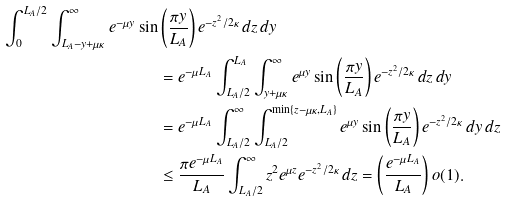Convert formula to latex. <formula><loc_0><loc_0><loc_500><loc_500>\int _ { 0 } ^ { L _ { A } / 2 } \int _ { L _ { A } - y + \mu \kappa } ^ { \infty } e ^ { - \mu y } \sin & \left ( \frac { \pi y } { L _ { A } } \right ) e ^ { - z ^ { 2 } / 2 \kappa } \, d z \, d y \\ & = e ^ { - \mu L _ { A } } \int _ { L _ { A } / 2 } ^ { L _ { A } } \int _ { y + \mu \kappa } ^ { \infty } e ^ { \mu y } \sin \left ( \frac { \pi y } { L _ { A } } \right ) e ^ { - z ^ { 2 } / 2 \kappa } \, d z \, d y \\ & = e ^ { - \mu L _ { A } } \int _ { L _ { A } / 2 } ^ { \infty } \int _ { L _ { A } / 2 } ^ { \min \{ z - \mu \kappa , L _ { A } \} } e ^ { \mu y } \sin \left ( \frac { \pi y } { L _ { A } } \right ) e ^ { - z ^ { 2 } / 2 \kappa } \, d y \, d z \\ & \leq \frac { \pi e ^ { - \mu L _ { A } } } { L _ { A } } \int _ { L _ { A } / 2 } ^ { \infty } z ^ { 2 } e ^ { \mu z } e ^ { - z ^ { 2 } / 2 \kappa } \, d z = \left ( \frac { e ^ { - \mu L _ { A } } } { L _ { A } } \right ) o ( 1 ) .</formula> 